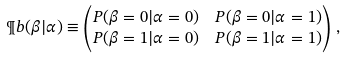<formula> <loc_0><loc_0><loc_500><loc_500>\P b ( \beta | \alpha ) & \equiv \begin{pmatrix} P ( \beta = 0 | \alpha = 0 ) & P ( \beta = 0 | \alpha = 1 ) \\ P ( \beta = 1 | \alpha = 0 ) & P ( \beta = 1 | \alpha = 1 ) \end{pmatrix} \, ,</formula> 